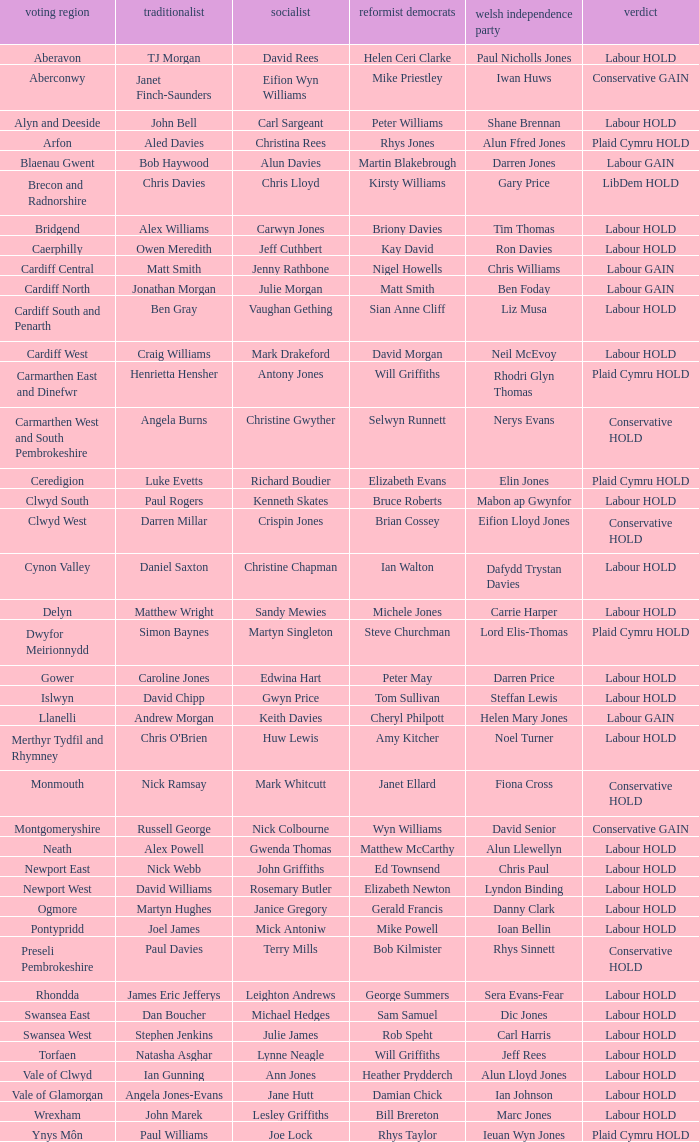What constituency does the Conservative Darren Millar belong to? Clwyd West. 